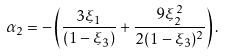Convert formula to latex. <formula><loc_0><loc_0><loc_500><loc_500>\alpha _ { 2 } = - \left ( \frac { 3 \xi _ { 1 } } { ( 1 - \xi _ { 3 } ) } + \frac { 9 \xi _ { 2 } ^ { 2 } } { 2 ( 1 - \xi _ { 3 } ) ^ { 2 } } \right ) .</formula> 